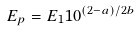<formula> <loc_0><loc_0><loc_500><loc_500>E _ { p } = E _ { 1 } 1 0 ^ { ( 2 - a ) / 2 b }</formula> 